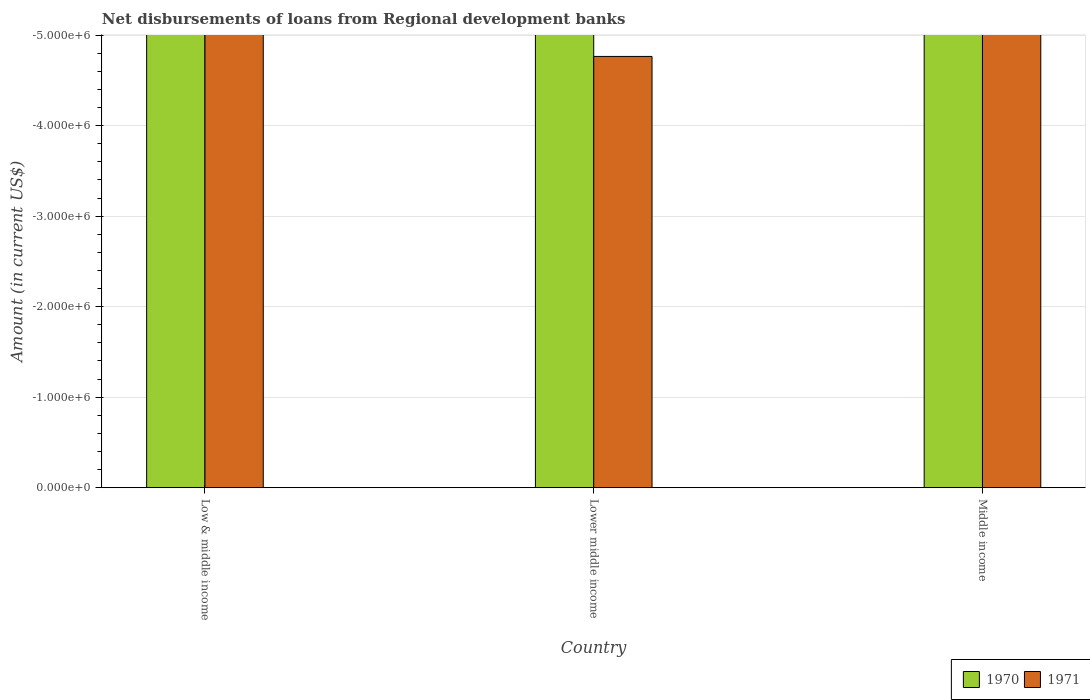How many bars are there on the 1st tick from the left?
Offer a terse response. 0. How many bars are there on the 1st tick from the right?
Your answer should be compact. 0. What is the amount of disbursements of loans from regional development banks in 1971 in Low & middle income?
Keep it short and to the point. 0. Across all countries, what is the minimum amount of disbursements of loans from regional development banks in 1971?
Offer a very short reply. 0. What is the total amount of disbursements of loans from regional development banks in 1971 in the graph?
Offer a very short reply. 0. What is the difference between the amount of disbursements of loans from regional development banks in 1971 in Lower middle income and the amount of disbursements of loans from regional development banks in 1970 in Low & middle income?
Offer a terse response. 0. In how many countries, is the amount of disbursements of loans from regional development banks in 1970 greater than the average amount of disbursements of loans from regional development banks in 1970 taken over all countries?
Offer a very short reply. 0. How many bars are there?
Provide a short and direct response. 0. Are all the bars in the graph horizontal?
Make the answer very short. No. What is the difference between two consecutive major ticks on the Y-axis?
Make the answer very short. 1.00e+06. Does the graph contain grids?
Provide a short and direct response. Yes. Where does the legend appear in the graph?
Your answer should be very brief. Bottom right. How are the legend labels stacked?
Offer a terse response. Horizontal. What is the title of the graph?
Your answer should be compact. Net disbursements of loans from Regional development banks. Does "1988" appear as one of the legend labels in the graph?
Keep it short and to the point. No. What is the label or title of the Y-axis?
Give a very brief answer. Amount (in current US$). What is the Amount (in current US$) of 1971 in Low & middle income?
Your response must be concise. 0. What is the Amount (in current US$) in 1970 in Lower middle income?
Give a very brief answer. 0. What is the Amount (in current US$) in 1971 in Lower middle income?
Provide a succinct answer. 0. What is the Amount (in current US$) of 1970 in Middle income?
Give a very brief answer. 0. What is the total Amount (in current US$) in 1970 in the graph?
Your response must be concise. 0. What is the total Amount (in current US$) in 1971 in the graph?
Your response must be concise. 0. What is the average Amount (in current US$) of 1970 per country?
Ensure brevity in your answer.  0. What is the average Amount (in current US$) of 1971 per country?
Provide a short and direct response. 0. 